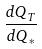<formula> <loc_0><loc_0><loc_500><loc_500>\frac { d Q _ { T } } { d Q _ { * } }</formula> 